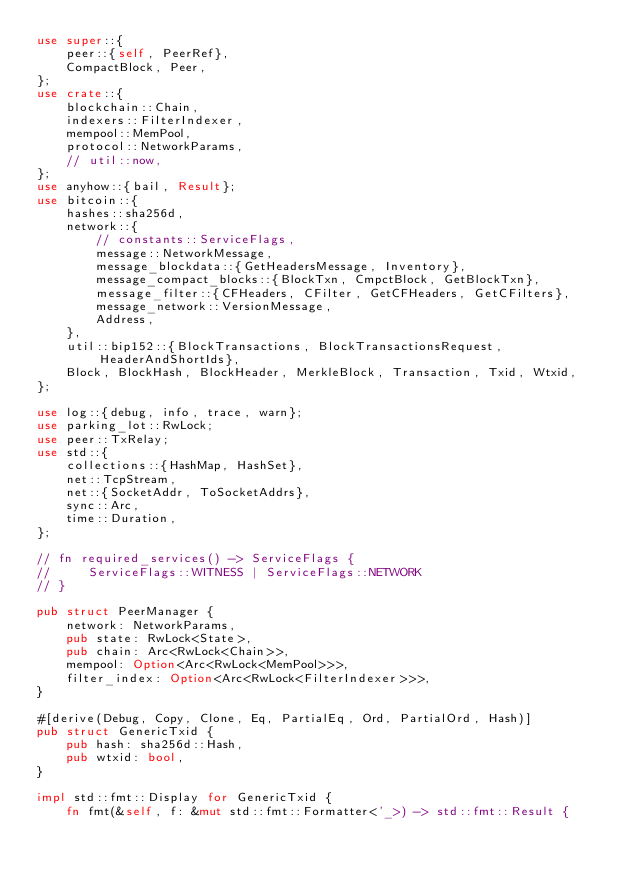<code> <loc_0><loc_0><loc_500><loc_500><_Rust_>use super::{
    peer::{self, PeerRef},
    CompactBlock, Peer,
};
use crate::{
    blockchain::Chain,
    indexers::FilterIndexer,
    mempool::MemPool,
    protocol::NetworkParams,
    // util::now,
};
use anyhow::{bail, Result};
use bitcoin::{
    hashes::sha256d,
    network::{
        // constants::ServiceFlags,
        message::NetworkMessage,
        message_blockdata::{GetHeadersMessage, Inventory},
        message_compact_blocks::{BlockTxn, CmpctBlock, GetBlockTxn},
        message_filter::{CFHeaders, CFilter, GetCFHeaders, GetCFilters},
        message_network::VersionMessage,
        Address,
    },
    util::bip152::{BlockTransactions, BlockTransactionsRequest, HeaderAndShortIds},
    Block, BlockHash, BlockHeader, MerkleBlock, Transaction, Txid, Wtxid,
};

use log::{debug, info, trace, warn};
use parking_lot::RwLock;
use peer::TxRelay;
use std::{
    collections::{HashMap, HashSet},
    net::TcpStream,
    net::{SocketAddr, ToSocketAddrs},
    sync::Arc,
    time::Duration,
};

// fn required_services() -> ServiceFlags {
//     ServiceFlags::WITNESS | ServiceFlags::NETWORK
// }

pub struct PeerManager {
    network: NetworkParams,
    pub state: RwLock<State>,
    pub chain: Arc<RwLock<Chain>>,
    mempool: Option<Arc<RwLock<MemPool>>>,
    filter_index: Option<Arc<RwLock<FilterIndexer>>>,
}

#[derive(Debug, Copy, Clone, Eq, PartialEq, Ord, PartialOrd, Hash)]
pub struct GenericTxid {
    pub hash: sha256d::Hash,
    pub wtxid: bool,
}

impl std::fmt::Display for GenericTxid {
    fn fmt(&self, f: &mut std::fmt::Formatter<'_>) -> std::fmt::Result {</code> 